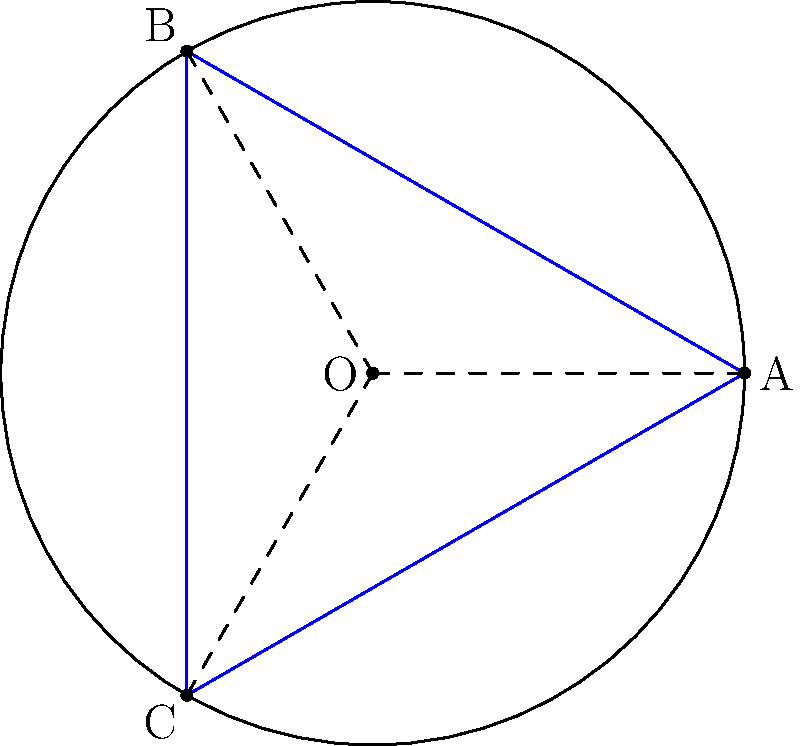Consider a spherical representation of your estate grounds, where points A, B, and C represent key attractions. Given that the sphere has a radius of 5 units and the central angles between each pair of points are 120°, what is the total distance of the most efficient guided tour path that visits all three attractions in the order A → B → C → A? To solve this problem, we'll use principles of elliptic geometry on a sphere:

1) In spherical geometry, the shortest path between two points is along a great circle, called a geodesic.

2) The length of an arc on a great circle is proportional to its central angle. The formula is:
   
   $s = R\theta$

   where $s$ is the arc length, $R$ is the radius of the sphere, and $\theta$ is the central angle in radians.

3) We're given that the central angles between each pair of points are 120°. We need to convert this to radians:

   $120° = 120 \cdot \frac{\pi}{180} = \frac{2\pi}{3}$ radians

4) Now we can calculate the length of each arc:

   $s = R\theta = 5 \cdot \frac{2\pi}{3} = \frac{10\pi}{3}$

5) Since we're visiting all three attractions and returning to the starting point, we'll traverse this arc three times.

6) Therefore, the total distance of the tour is:

   $3 \cdot \frac{10\pi}{3} = 10\pi$

Thus, the most efficient guided tour path has a total distance of $10\pi$ units.
Answer: $10\pi$ units 